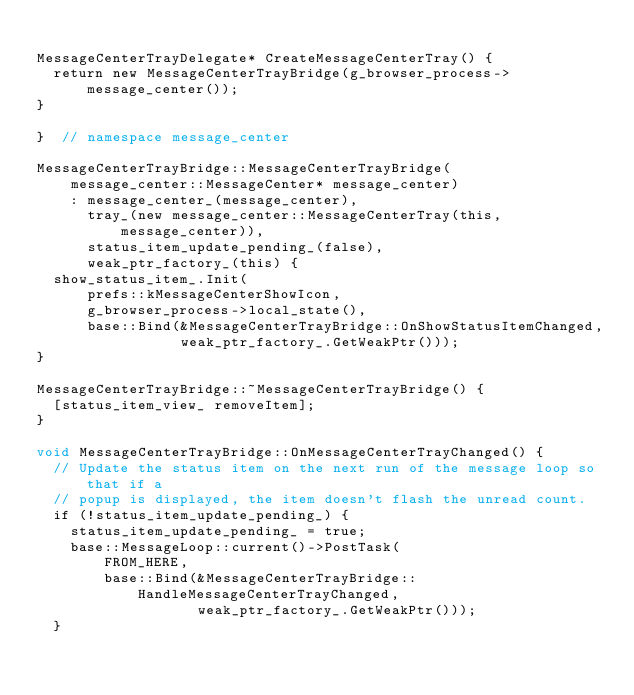Convert code to text. <code><loc_0><loc_0><loc_500><loc_500><_ObjectiveC_>
MessageCenterTrayDelegate* CreateMessageCenterTray() {
  return new MessageCenterTrayBridge(g_browser_process->message_center());
}

}  // namespace message_center

MessageCenterTrayBridge::MessageCenterTrayBridge(
    message_center::MessageCenter* message_center)
    : message_center_(message_center),
      tray_(new message_center::MessageCenterTray(this, message_center)),
      status_item_update_pending_(false),
      weak_ptr_factory_(this) {
  show_status_item_.Init(
      prefs::kMessageCenterShowIcon,
      g_browser_process->local_state(),
      base::Bind(&MessageCenterTrayBridge::OnShowStatusItemChanged,
                 weak_ptr_factory_.GetWeakPtr()));
}

MessageCenterTrayBridge::~MessageCenterTrayBridge() {
  [status_item_view_ removeItem];
}

void MessageCenterTrayBridge::OnMessageCenterTrayChanged() {
  // Update the status item on the next run of the message loop so that if a
  // popup is displayed, the item doesn't flash the unread count.
  if (!status_item_update_pending_) {
    status_item_update_pending_ = true;
    base::MessageLoop::current()->PostTask(
        FROM_HERE,
        base::Bind(&MessageCenterTrayBridge::HandleMessageCenterTrayChanged,
                   weak_ptr_factory_.GetWeakPtr()));
  }
</code> 